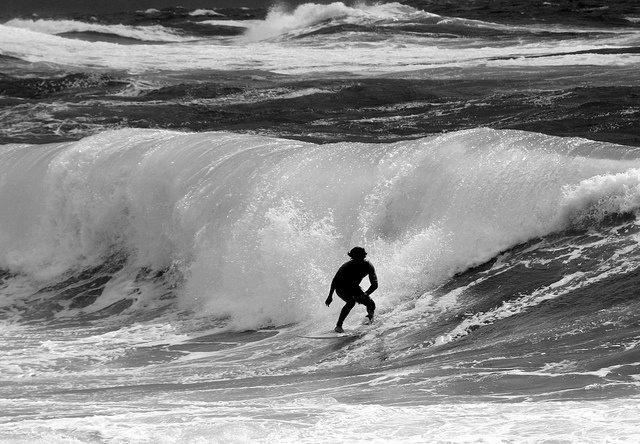Describe the objects in this image and their specific colors. I can see people in black, lightgray, gray, and darkgray tones and surfboard in black, darkgray, gray, and lightgray tones in this image. 